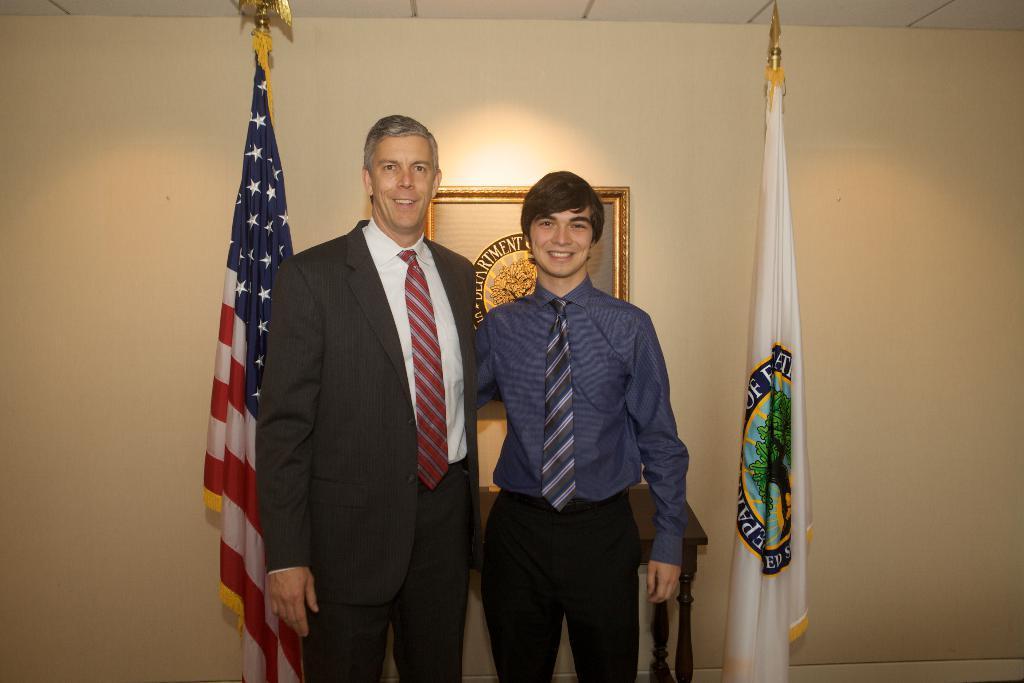In one or two sentences, can you explain what this image depicts? As we can see in the image there is a wall, flags, two people standing over here and photo frame. The person over here is wearing blue color shirt and the person next to him is wearing black color jacket. 